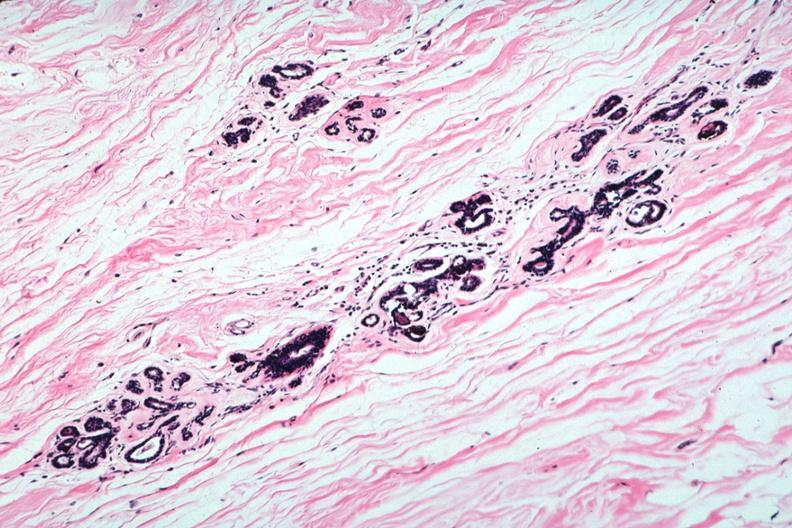s atrophy present?
Answer the question using a single word or phrase. Yes 